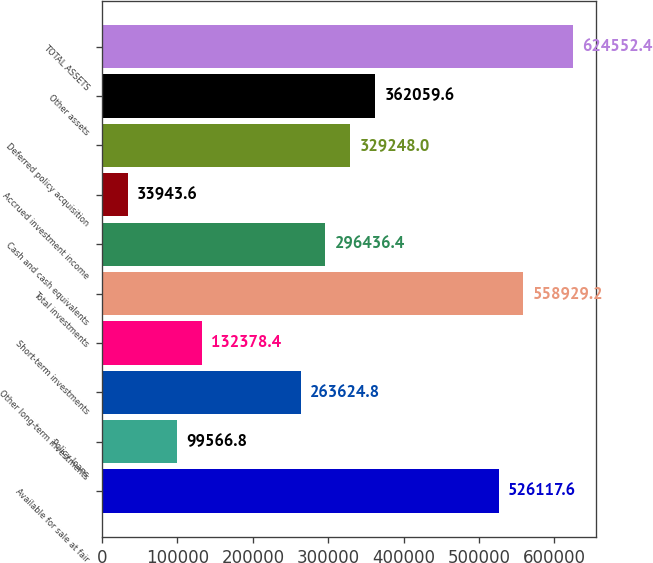Convert chart to OTSL. <chart><loc_0><loc_0><loc_500><loc_500><bar_chart><fcel>Available for sale at fair<fcel>Policy loans<fcel>Other long-term investments<fcel>Short-term investments<fcel>Total investments<fcel>Cash and cash equivalents<fcel>Accrued investment income<fcel>Deferred policy acquisition<fcel>Other assets<fcel>TOTAL ASSETS<nl><fcel>526118<fcel>99566.8<fcel>263625<fcel>132378<fcel>558929<fcel>296436<fcel>33943.6<fcel>329248<fcel>362060<fcel>624552<nl></chart> 